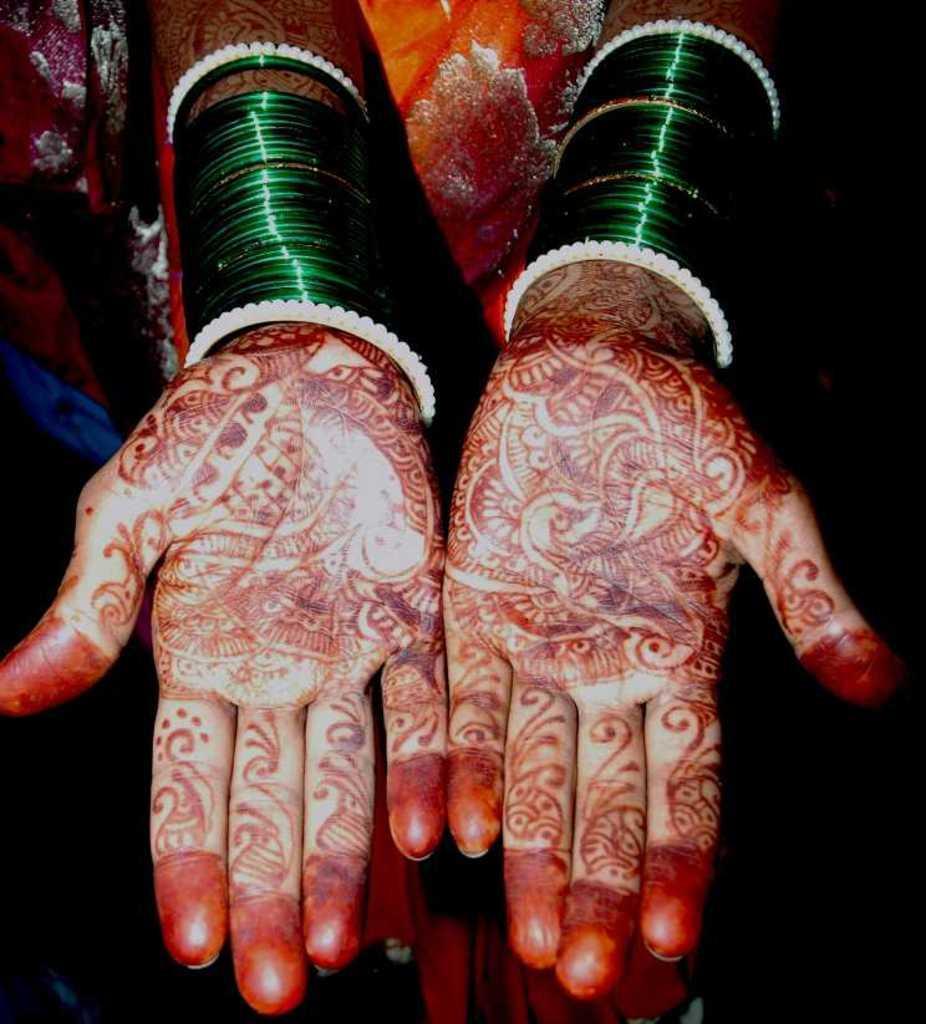Can you describe this image briefly? In this image we can see hands of a lady with bangles. On the hands there is henna designs. 